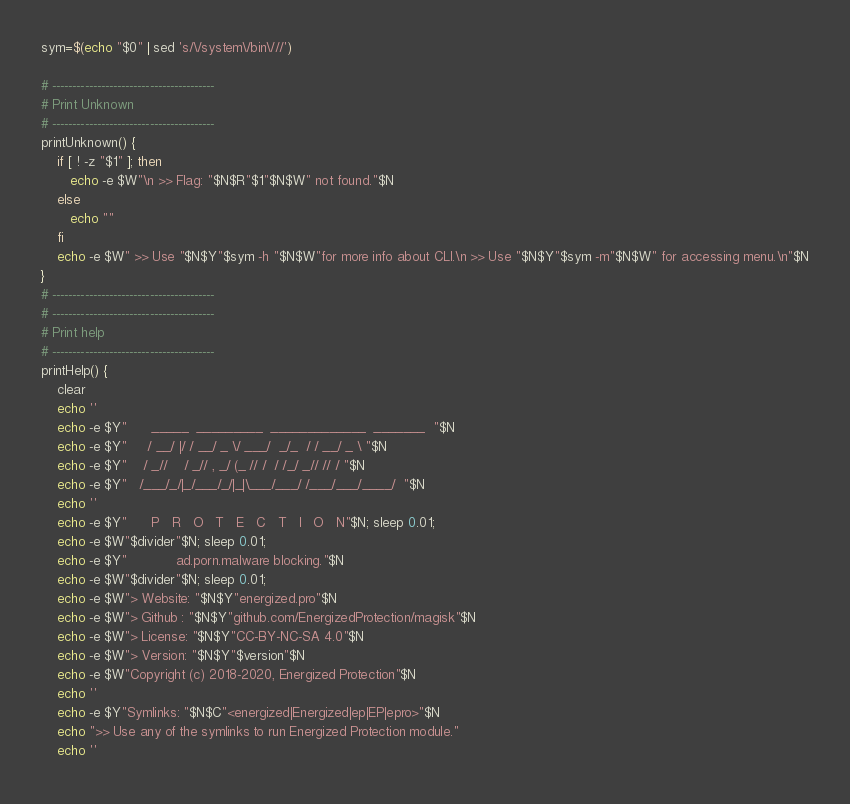Convert code to text. <code><loc_0><loc_0><loc_500><loc_500><_Bash_>sym=$(echo "$0" | sed 's/\/system\/bin\///')

# ----------------------------------------
# Print Unknown
# ----------------------------------------
printUnknown() {
	if [ ! -z "$1" ]; then
	   echo -e $W"\n >> Flag: "$N$R"$1"$N$W" not found."$N
	else
	   echo ""
	fi
	echo -e $W" >> Use "$N$Y"$sym -h "$N$W"for more info about CLI.\n >> Use "$N$Y"$sym -m"$N$W" for accessing menu.\n"$N
}
# ----------------------------------------
# ----------------------------------------
# Print help
# ----------------------------------------
printHelp() {
	clear
    echo ''
    echo -e $Y"      _____  _________  _____________  _______  "$N
    echo -e $Y"     / __/ |/ / __/ _ \/ ___/  _/_  / / __/ _ \ "$N
    echo -e $Y"    / _//    / _// , _/ (_ // /  / /_/ _// // / "$N
    echo -e $Y"   /___/_/|_/___/_/|_|\___/___/ /___/___/____/  "$N
    echo ''
    echo -e $Y"      P   R   O   T   E   C   T   I   O   N"$N; sleep 0.01;
    echo -e $W"$divider"$N; sleep 0.01;
    echo -e $Y"            ad.porn.malware blocking."$N
    echo -e $W"$divider"$N; sleep 0.01;
    echo -e $W"> Website: "$N$Y"energized.pro"$N 
    echo -e $W"> Github : "$N$Y"github.com/EnergizedProtection/magisk"$N
    echo -e $W"> License: "$N$Y"CC-BY-NC-SA 4.0"$N
    echo -e $W"> Version: "$N$Y"$version"$N
    echo -e $W"Copyright (c) 2018-2020, Energized Protection"$N
    echo ''
    echo -e $Y"Symlinks: "$N$C"<energized|Energized|ep|EP|epro>"$N
    echo ">> Use any of the symlinks to run Energized Protection module."
    echo ''</code> 